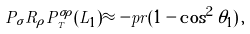Convert formula to latex. <formula><loc_0><loc_0><loc_500><loc_500>P _ { \sigma } R _ { \rho } P ^ { \sigma \rho } _ { _ { T } } ( L _ { 1 } ) \approx - p r ( 1 - \cos ^ { 2 } \theta _ { 1 } ) \, ,</formula> 